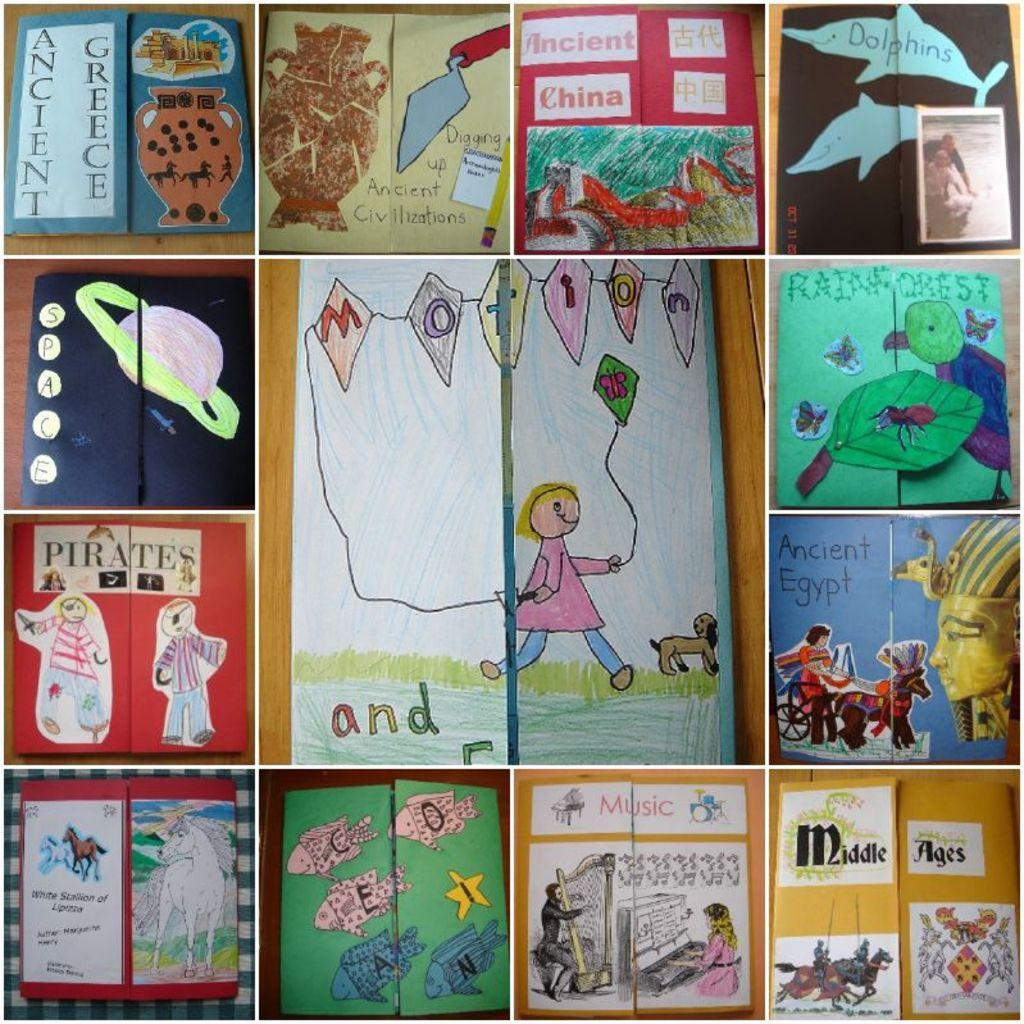What is the main subject of the image? The main subject of the image is a collage of paintings. Can you describe the paintings in the collage? Unfortunately, the specific details of the paintings cannot be determined from the image alone. How are the paintings arranged in the collage? The arrangement of the paintings in the collage cannot be determined from the image alone. What type of mice can be seen interacting with the paintings in the image? There are no mice present in the image; it features a collage of paintings. 